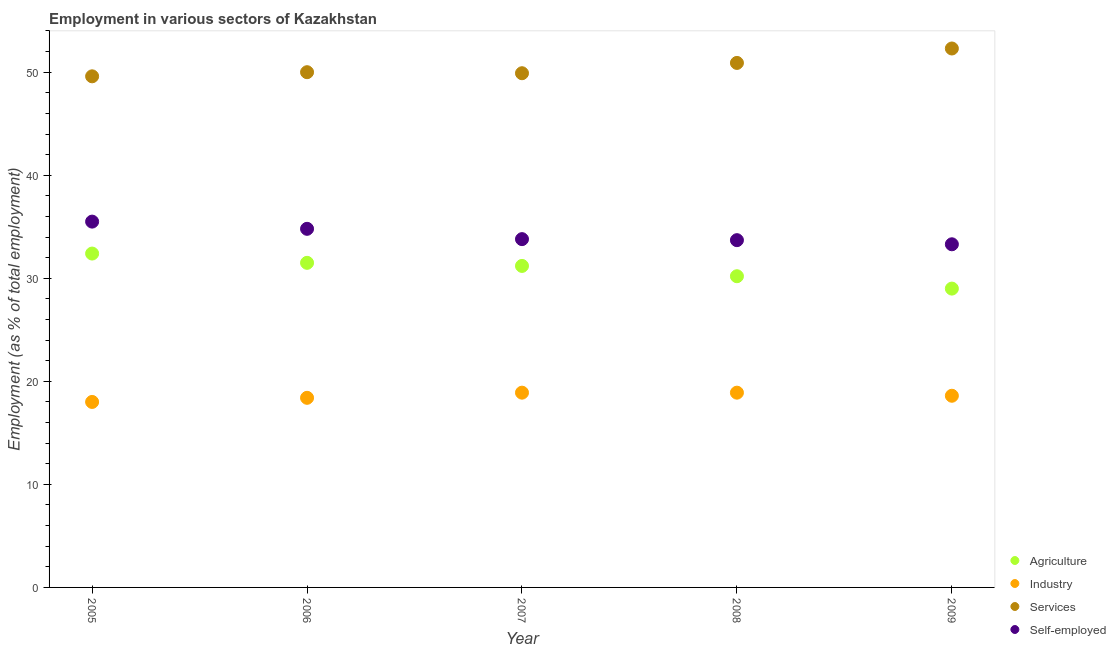What is the percentage of workers in services in 2006?
Your response must be concise. 50. Across all years, what is the maximum percentage of self employed workers?
Your response must be concise. 35.5. Across all years, what is the minimum percentage of workers in services?
Make the answer very short. 49.6. What is the total percentage of workers in agriculture in the graph?
Give a very brief answer. 154.3. What is the difference between the percentage of workers in services in 2006 and that in 2008?
Give a very brief answer. -0.9. What is the difference between the percentage of workers in agriculture in 2009 and the percentage of self employed workers in 2008?
Your answer should be very brief. -4.7. What is the average percentage of workers in industry per year?
Provide a short and direct response. 18.56. In the year 2008, what is the difference between the percentage of workers in industry and percentage of workers in agriculture?
Provide a short and direct response. -11.3. What is the ratio of the percentage of workers in agriculture in 2008 to that in 2009?
Make the answer very short. 1.04. What is the difference between the highest and the second highest percentage of self employed workers?
Ensure brevity in your answer.  0.7. What is the difference between the highest and the lowest percentage of self employed workers?
Ensure brevity in your answer.  2.2. In how many years, is the percentage of self employed workers greater than the average percentage of self employed workers taken over all years?
Make the answer very short. 2. Is the sum of the percentage of workers in agriculture in 2006 and 2009 greater than the maximum percentage of self employed workers across all years?
Your answer should be compact. Yes. Is it the case that in every year, the sum of the percentage of workers in services and percentage of workers in industry is greater than the sum of percentage of self employed workers and percentage of workers in agriculture?
Give a very brief answer. Yes. Does the percentage of workers in services monotonically increase over the years?
Offer a very short reply. No. Is the percentage of self employed workers strictly less than the percentage of workers in services over the years?
Make the answer very short. Yes. Does the graph contain grids?
Ensure brevity in your answer.  No. How many legend labels are there?
Provide a succinct answer. 4. What is the title of the graph?
Keep it short and to the point. Employment in various sectors of Kazakhstan. Does "Others" appear as one of the legend labels in the graph?
Ensure brevity in your answer.  No. What is the label or title of the X-axis?
Provide a succinct answer. Year. What is the label or title of the Y-axis?
Your response must be concise. Employment (as % of total employment). What is the Employment (as % of total employment) of Agriculture in 2005?
Your answer should be very brief. 32.4. What is the Employment (as % of total employment) of Industry in 2005?
Your answer should be compact. 18. What is the Employment (as % of total employment) of Services in 2005?
Your response must be concise. 49.6. What is the Employment (as % of total employment) in Self-employed in 2005?
Provide a succinct answer. 35.5. What is the Employment (as % of total employment) in Agriculture in 2006?
Offer a terse response. 31.5. What is the Employment (as % of total employment) of Industry in 2006?
Provide a succinct answer. 18.4. What is the Employment (as % of total employment) in Self-employed in 2006?
Keep it short and to the point. 34.8. What is the Employment (as % of total employment) in Agriculture in 2007?
Provide a succinct answer. 31.2. What is the Employment (as % of total employment) of Industry in 2007?
Offer a very short reply. 18.9. What is the Employment (as % of total employment) of Services in 2007?
Ensure brevity in your answer.  49.9. What is the Employment (as % of total employment) of Self-employed in 2007?
Your answer should be compact. 33.8. What is the Employment (as % of total employment) of Agriculture in 2008?
Make the answer very short. 30.2. What is the Employment (as % of total employment) in Industry in 2008?
Give a very brief answer. 18.9. What is the Employment (as % of total employment) in Services in 2008?
Make the answer very short. 50.9. What is the Employment (as % of total employment) in Self-employed in 2008?
Provide a succinct answer. 33.7. What is the Employment (as % of total employment) of Industry in 2009?
Your response must be concise. 18.6. What is the Employment (as % of total employment) in Services in 2009?
Give a very brief answer. 52.3. What is the Employment (as % of total employment) of Self-employed in 2009?
Keep it short and to the point. 33.3. Across all years, what is the maximum Employment (as % of total employment) of Agriculture?
Your answer should be very brief. 32.4. Across all years, what is the maximum Employment (as % of total employment) in Industry?
Your response must be concise. 18.9. Across all years, what is the maximum Employment (as % of total employment) of Services?
Provide a short and direct response. 52.3. Across all years, what is the maximum Employment (as % of total employment) of Self-employed?
Offer a very short reply. 35.5. Across all years, what is the minimum Employment (as % of total employment) of Services?
Your answer should be compact. 49.6. Across all years, what is the minimum Employment (as % of total employment) in Self-employed?
Offer a terse response. 33.3. What is the total Employment (as % of total employment) in Agriculture in the graph?
Your answer should be compact. 154.3. What is the total Employment (as % of total employment) in Industry in the graph?
Make the answer very short. 92.8. What is the total Employment (as % of total employment) of Services in the graph?
Your answer should be very brief. 252.7. What is the total Employment (as % of total employment) in Self-employed in the graph?
Offer a terse response. 171.1. What is the difference between the Employment (as % of total employment) of Agriculture in 2005 and that in 2006?
Provide a succinct answer. 0.9. What is the difference between the Employment (as % of total employment) in Self-employed in 2005 and that in 2006?
Give a very brief answer. 0.7. What is the difference between the Employment (as % of total employment) in Services in 2005 and that in 2007?
Your answer should be very brief. -0.3. What is the difference between the Employment (as % of total employment) of Self-employed in 2005 and that in 2007?
Provide a succinct answer. 1.7. What is the difference between the Employment (as % of total employment) in Self-employed in 2005 and that in 2008?
Your answer should be very brief. 1.8. What is the difference between the Employment (as % of total employment) of Agriculture in 2005 and that in 2009?
Ensure brevity in your answer.  3.4. What is the difference between the Employment (as % of total employment) in Industry in 2005 and that in 2009?
Provide a succinct answer. -0.6. What is the difference between the Employment (as % of total employment) of Self-employed in 2006 and that in 2007?
Provide a short and direct response. 1. What is the difference between the Employment (as % of total employment) in Agriculture in 2006 and that in 2008?
Your answer should be compact. 1.3. What is the difference between the Employment (as % of total employment) in Industry in 2006 and that in 2008?
Your answer should be compact. -0.5. What is the difference between the Employment (as % of total employment) in Services in 2006 and that in 2008?
Make the answer very short. -0.9. What is the difference between the Employment (as % of total employment) in Agriculture in 2006 and that in 2009?
Your answer should be very brief. 2.5. What is the difference between the Employment (as % of total employment) of Industry in 2006 and that in 2009?
Keep it short and to the point. -0.2. What is the difference between the Employment (as % of total employment) of Services in 2007 and that in 2008?
Your response must be concise. -1. What is the difference between the Employment (as % of total employment) of Self-employed in 2007 and that in 2008?
Ensure brevity in your answer.  0.1. What is the difference between the Employment (as % of total employment) of Industry in 2007 and that in 2009?
Give a very brief answer. 0.3. What is the difference between the Employment (as % of total employment) in Services in 2007 and that in 2009?
Ensure brevity in your answer.  -2.4. What is the difference between the Employment (as % of total employment) of Self-employed in 2007 and that in 2009?
Give a very brief answer. 0.5. What is the difference between the Employment (as % of total employment) in Industry in 2008 and that in 2009?
Give a very brief answer. 0.3. What is the difference between the Employment (as % of total employment) in Self-employed in 2008 and that in 2009?
Keep it short and to the point. 0.4. What is the difference between the Employment (as % of total employment) of Agriculture in 2005 and the Employment (as % of total employment) of Services in 2006?
Provide a short and direct response. -17.6. What is the difference between the Employment (as % of total employment) in Agriculture in 2005 and the Employment (as % of total employment) in Self-employed in 2006?
Your answer should be compact. -2.4. What is the difference between the Employment (as % of total employment) in Industry in 2005 and the Employment (as % of total employment) in Services in 2006?
Offer a terse response. -32. What is the difference between the Employment (as % of total employment) of Industry in 2005 and the Employment (as % of total employment) of Self-employed in 2006?
Provide a succinct answer. -16.8. What is the difference between the Employment (as % of total employment) in Services in 2005 and the Employment (as % of total employment) in Self-employed in 2006?
Your answer should be very brief. 14.8. What is the difference between the Employment (as % of total employment) of Agriculture in 2005 and the Employment (as % of total employment) of Services in 2007?
Ensure brevity in your answer.  -17.5. What is the difference between the Employment (as % of total employment) in Agriculture in 2005 and the Employment (as % of total employment) in Self-employed in 2007?
Your response must be concise. -1.4. What is the difference between the Employment (as % of total employment) of Industry in 2005 and the Employment (as % of total employment) of Services in 2007?
Your answer should be very brief. -31.9. What is the difference between the Employment (as % of total employment) in Industry in 2005 and the Employment (as % of total employment) in Self-employed in 2007?
Give a very brief answer. -15.8. What is the difference between the Employment (as % of total employment) in Agriculture in 2005 and the Employment (as % of total employment) in Services in 2008?
Your response must be concise. -18.5. What is the difference between the Employment (as % of total employment) of Agriculture in 2005 and the Employment (as % of total employment) of Self-employed in 2008?
Offer a very short reply. -1.3. What is the difference between the Employment (as % of total employment) in Industry in 2005 and the Employment (as % of total employment) in Services in 2008?
Your response must be concise. -32.9. What is the difference between the Employment (as % of total employment) in Industry in 2005 and the Employment (as % of total employment) in Self-employed in 2008?
Provide a succinct answer. -15.7. What is the difference between the Employment (as % of total employment) of Services in 2005 and the Employment (as % of total employment) of Self-employed in 2008?
Your answer should be very brief. 15.9. What is the difference between the Employment (as % of total employment) in Agriculture in 2005 and the Employment (as % of total employment) in Services in 2009?
Ensure brevity in your answer.  -19.9. What is the difference between the Employment (as % of total employment) in Industry in 2005 and the Employment (as % of total employment) in Services in 2009?
Keep it short and to the point. -34.3. What is the difference between the Employment (as % of total employment) in Industry in 2005 and the Employment (as % of total employment) in Self-employed in 2009?
Provide a short and direct response. -15.3. What is the difference between the Employment (as % of total employment) of Services in 2005 and the Employment (as % of total employment) of Self-employed in 2009?
Ensure brevity in your answer.  16.3. What is the difference between the Employment (as % of total employment) in Agriculture in 2006 and the Employment (as % of total employment) in Industry in 2007?
Give a very brief answer. 12.6. What is the difference between the Employment (as % of total employment) in Agriculture in 2006 and the Employment (as % of total employment) in Services in 2007?
Provide a succinct answer. -18.4. What is the difference between the Employment (as % of total employment) in Agriculture in 2006 and the Employment (as % of total employment) in Self-employed in 2007?
Provide a succinct answer. -2.3. What is the difference between the Employment (as % of total employment) in Industry in 2006 and the Employment (as % of total employment) in Services in 2007?
Your response must be concise. -31.5. What is the difference between the Employment (as % of total employment) of Industry in 2006 and the Employment (as % of total employment) of Self-employed in 2007?
Keep it short and to the point. -15.4. What is the difference between the Employment (as % of total employment) in Services in 2006 and the Employment (as % of total employment) in Self-employed in 2007?
Your answer should be compact. 16.2. What is the difference between the Employment (as % of total employment) in Agriculture in 2006 and the Employment (as % of total employment) in Services in 2008?
Provide a short and direct response. -19.4. What is the difference between the Employment (as % of total employment) in Agriculture in 2006 and the Employment (as % of total employment) in Self-employed in 2008?
Ensure brevity in your answer.  -2.2. What is the difference between the Employment (as % of total employment) in Industry in 2006 and the Employment (as % of total employment) in Services in 2008?
Your answer should be compact. -32.5. What is the difference between the Employment (as % of total employment) in Industry in 2006 and the Employment (as % of total employment) in Self-employed in 2008?
Your answer should be very brief. -15.3. What is the difference between the Employment (as % of total employment) in Services in 2006 and the Employment (as % of total employment) in Self-employed in 2008?
Provide a short and direct response. 16.3. What is the difference between the Employment (as % of total employment) in Agriculture in 2006 and the Employment (as % of total employment) in Services in 2009?
Your answer should be compact. -20.8. What is the difference between the Employment (as % of total employment) of Agriculture in 2006 and the Employment (as % of total employment) of Self-employed in 2009?
Offer a terse response. -1.8. What is the difference between the Employment (as % of total employment) in Industry in 2006 and the Employment (as % of total employment) in Services in 2009?
Your answer should be very brief. -33.9. What is the difference between the Employment (as % of total employment) of Industry in 2006 and the Employment (as % of total employment) of Self-employed in 2009?
Your answer should be very brief. -14.9. What is the difference between the Employment (as % of total employment) in Services in 2006 and the Employment (as % of total employment) in Self-employed in 2009?
Provide a short and direct response. 16.7. What is the difference between the Employment (as % of total employment) in Agriculture in 2007 and the Employment (as % of total employment) in Services in 2008?
Your answer should be compact. -19.7. What is the difference between the Employment (as % of total employment) in Industry in 2007 and the Employment (as % of total employment) in Services in 2008?
Give a very brief answer. -32. What is the difference between the Employment (as % of total employment) of Industry in 2007 and the Employment (as % of total employment) of Self-employed in 2008?
Provide a succinct answer. -14.8. What is the difference between the Employment (as % of total employment) of Agriculture in 2007 and the Employment (as % of total employment) of Industry in 2009?
Provide a short and direct response. 12.6. What is the difference between the Employment (as % of total employment) of Agriculture in 2007 and the Employment (as % of total employment) of Services in 2009?
Your response must be concise. -21.1. What is the difference between the Employment (as % of total employment) of Agriculture in 2007 and the Employment (as % of total employment) of Self-employed in 2009?
Provide a short and direct response. -2.1. What is the difference between the Employment (as % of total employment) in Industry in 2007 and the Employment (as % of total employment) in Services in 2009?
Provide a short and direct response. -33.4. What is the difference between the Employment (as % of total employment) of Industry in 2007 and the Employment (as % of total employment) of Self-employed in 2009?
Provide a short and direct response. -14.4. What is the difference between the Employment (as % of total employment) of Services in 2007 and the Employment (as % of total employment) of Self-employed in 2009?
Give a very brief answer. 16.6. What is the difference between the Employment (as % of total employment) in Agriculture in 2008 and the Employment (as % of total employment) in Industry in 2009?
Offer a terse response. 11.6. What is the difference between the Employment (as % of total employment) in Agriculture in 2008 and the Employment (as % of total employment) in Services in 2009?
Make the answer very short. -22.1. What is the difference between the Employment (as % of total employment) in Industry in 2008 and the Employment (as % of total employment) in Services in 2009?
Keep it short and to the point. -33.4. What is the difference between the Employment (as % of total employment) in Industry in 2008 and the Employment (as % of total employment) in Self-employed in 2009?
Give a very brief answer. -14.4. What is the difference between the Employment (as % of total employment) of Services in 2008 and the Employment (as % of total employment) of Self-employed in 2009?
Your answer should be compact. 17.6. What is the average Employment (as % of total employment) in Agriculture per year?
Provide a short and direct response. 30.86. What is the average Employment (as % of total employment) in Industry per year?
Offer a very short reply. 18.56. What is the average Employment (as % of total employment) of Services per year?
Offer a very short reply. 50.54. What is the average Employment (as % of total employment) of Self-employed per year?
Your answer should be compact. 34.22. In the year 2005, what is the difference between the Employment (as % of total employment) in Agriculture and Employment (as % of total employment) in Services?
Your answer should be compact. -17.2. In the year 2005, what is the difference between the Employment (as % of total employment) in Agriculture and Employment (as % of total employment) in Self-employed?
Your response must be concise. -3.1. In the year 2005, what is the difference between the Employment (as % of total employment) in Industry and Employment (as % of total employment) in Services?
Your answer should be very brief. -31.6. In the year 2005, what is the difference between the Employment (as % of total employment) of Industry and Employment (as % of total employment) of Self-employed?
Give a very brief answer. -17.5. In the year 2006, what is the difference between the Employment (as % of total employment) of Agriculture and Employment (as % of total employment) of Services?
Ensure brevity in your answer.  -18.5. In the year 2006, what is the difference between the Employment (as % of total employment) of Agriculture and Employment (as % of total employment) of Self-employed?
Your answer should be compact. -3.3. In the year 2006, what is the difference between the Employment (as % of total employment) in Industry and Employment (as % of total employment) in Services?
Make the answer very short. -31.6. In the year 2006, what is the difference between the Employment (as % of total employment) of Industry and Employment (as % of total employment) of Self-employed?
Provide a succinct answer. -16.4. In the year 2006, what is the difference between the Employment (as % of total employment) of Services and Employment (as % of total employment) of Self-employed?
Your answer should be very brief. 15.2. In the year 2007, what is the difference between the Employment (as % of total employment) of Agriculture and Employment (as % of total employment) of Services?
Provide a short and direct response. -18.7. In the year 2007, what is the difference between the Employment (as % of total employment) of Agriculture and Employment (as % of total employment) of Self-employed?
Your response must be concise. -2.6. In the year 2007, what is the difference between the Employment (as % of total employment) in Industry and Employment (as % of total employment) in Services?
Offer a very short reply. -31. In the year 2007, what is the difference between the Employment (as % of total employment) in Industry and Employment (as % of total employment) in Self-employed?
Your answer should be compact. -14.9. In the year 2008, what is the difference between the Employment (as % of total employment) of Agriculture and Employment (as % of total employment) of Services?
Offer a very short reply. -20.7. In the year 2008, what is the difference between the Employment (as % of total employment) of Industry and Employment (as % of total employment) of Services?
Offer a very short reply. -32. In the year 2008, what is the difference between the Employment (as % of total employment) in Industry and Employment (as % of total employment) in Self-employed?
Your response must be concise. -14.8. In the year 2009, what is the difference between the Employment (as % of total employment) of Agriculture and Employment (as % of total employment) of Industry?
Provide a succinct answer. 10.4. In the year 2009, what is the difference between the Employment (as % of total employment) of Agriculture and Employment (as % of total employment) of Services?
Offer a very short reply. -23.3. In the year 2009, what is the difference between the Employment (as % of total employment) in Agriculture and Employment (as % of total employment) in Self-employed?
Ensure brevity in your answer.  -4.3. In the year 2009, what is the difference between the Employment (as % of total employment) in Industry and Employment (as % of total employment) in Services?
Your response must be concise. -33.7. In the year 2009, what is the difference between the Employment (as % of total employment) of Industry and Employment (as % of total employment) of Self-employed?
Keep it short and to the point. -14.7. In the year 2009, what is the difference between the Employment (as % of total employment) of Services and Employment (as % of total employment) of Self-employed?
Give a very brief answer. 19. What is the ratio of the Employment (as % of total employment) in Agriculture in 2005 to that in 2006?
Make the answer very short. 1.03. What is the ratio of the Employment (as % of total employment) in Industry in 2005 to that in 2006?
Give a very brief answer. 0.98. What is the ratio of the Employment (as % of total employment) of Self-employed in 2005 to that in 2006?
Your answer should be compact. 1.02. What is the ratio of the Employment (as % of total employment) in Industry in 2005 to that in 2007?
Ensure brevity in your answer.  0.95. What is the ratio of the Employment (as % of total employment) of Services in 2005 to that in 2007?
Provide a short and direct response. 0.99. What is the ratio of the Employment (as % of total employment) in Self-employed in 2005 to that in 2007?
Provide a short and direct response. 1.05. What is the ratio of the Employment (as % of total employment) of Agriculture in 2005 to that in 2008?
Offer a terse response. 1.07. What is the ratio of the Employment (as % of total employment) in Services in 2005 to that in 2008?
Give a very brief answer. 0.97. What is the ratio of the Employment (as % of total employment) of Self-employed in 2005 to that in 2008?
Your response must be concise. 1.05. What is the ratio of the Employment (as % of total employment) in Agriculture in 2005 to that in 2009?
Your answer should be very brief. 1.12. What is the ratio of the Employment (as % of total employment) in Industry in 2005 to that in 2009?
Ensure brevity in your answer.  0.97. What is the ratio of the Employment (as % of total employment) in Services in 2005 to that in 2009?
Offer a terse response. 0.95. What is the ratio of the Employment (as % of total employment) in Self-employed in 2005 to that in 2009?
Provide a short and direct response. 1.07. What is the ratio of the Employment (as % of total employment) of Agriculture in 2006 to that in 2007?
Your answer should be very brief. 1.01. What is the ratio of the Employment (as % of total employment) of Industry in 2006 to that in 2007?
Offer a terse response. 0.97. What is the ratio of the Employment (as % of total employment) of Services in 2006 to that in 2007?
Provide a short and direct response. 1. What is the ratio of the Employment (as % of total employment) in Self-employed in 2006 to that in 2007?
Your response must be concise. 1.03. What is the ratio of the Employment (as % of total employment) in Agriculture in 2006 to that in 2008?
Give a very brief answer. 1.04. What is the ratio of the Employment (as % of total employment) of Industry in 2006 to that in 2008?
Offer a very short reply. 0.97. What is the ratio of the Employment (as % of total employment) of Services in 2006 to that in 2008?
Give a very brief answer. 0.98. What is the ratio of the Employment (as % of total employment) in Self-employed in 2006 to that in 2008?
Offer a very short reply. 1.03. What is the ratio of the Employment (as % of total employment) in Agriculture in 2006 to that in 2009?
Make the answer very short. 1.09. What is the ratio of the Employment (as % of total employment) in Industry in 2006 to that in 2009?
Offer a terse response. 0.99. What is the ratio of the Employment (as % of total employment) of Services in 2006 to that in 2009?
Provide a succinct answer. 0.96. What is the ratio of the Employment (as % of total employment) in Self-employed in 2006 to that in 2009?
Your response must be concise. 1.04. What is the ratio of the Employment (as % of total employment) of Agriculture in 2007 to that in 2008?
Ensure brevity in your answer.  1.03. What is the ratio of the Employment (as % of total employment) in Industry in 2007 to that in 2008?
Your answer should be very brief. 1. What is the ratio of the Employment (as % of total employment) in Services in 2007 to that in 2008?
Your answer should be very brief. 0.98. What is the ratio of the Employment (as % of total employment) of Agriculture in 2007 to that in 2009?
Keep it short and to the point. 1.08. What is the ratio of the Employment (as % of total employment) in Industry in 2007 to that in 2009?
Keep it short and to the point. 1.02. What is the ratio of the Employment (as % of total employment) in Services in 2007 to that in 2009?
Keep it short and to the point. 0.95. What is the ratio of the Employment (as % of total employment) of Agriculture in 2008 to that in 2009?
Ensure brevity in your answer.  1.04. What is the ratio of the Employment (as % of total employment) in Industry in 2008 to that in 2009?
Provide a succinct answer. 1.02. What is the ratio of the Employment (as % of total employment) of Services in 2008 to that in 2009?
Offer a very short reply. 0.97. What is the ratio of the Employment (as % of total employment) in Self-employed in 2008 to that in 2009?
Your answer should be compact. 1.01. What is the difference between the highest and the second highest Employment (as % of total employment) of Agriculture?
Your answer should be very brief. 0.9. What is the difference between the highest and the second highest Employment (as % of total employment) of Self-employed?
Provide a short and direct response. 0.7. What is the difference between the highest and the lowest Employment (as % of total employment) in Self-employed?
Give a very brief answer. 2.2. 